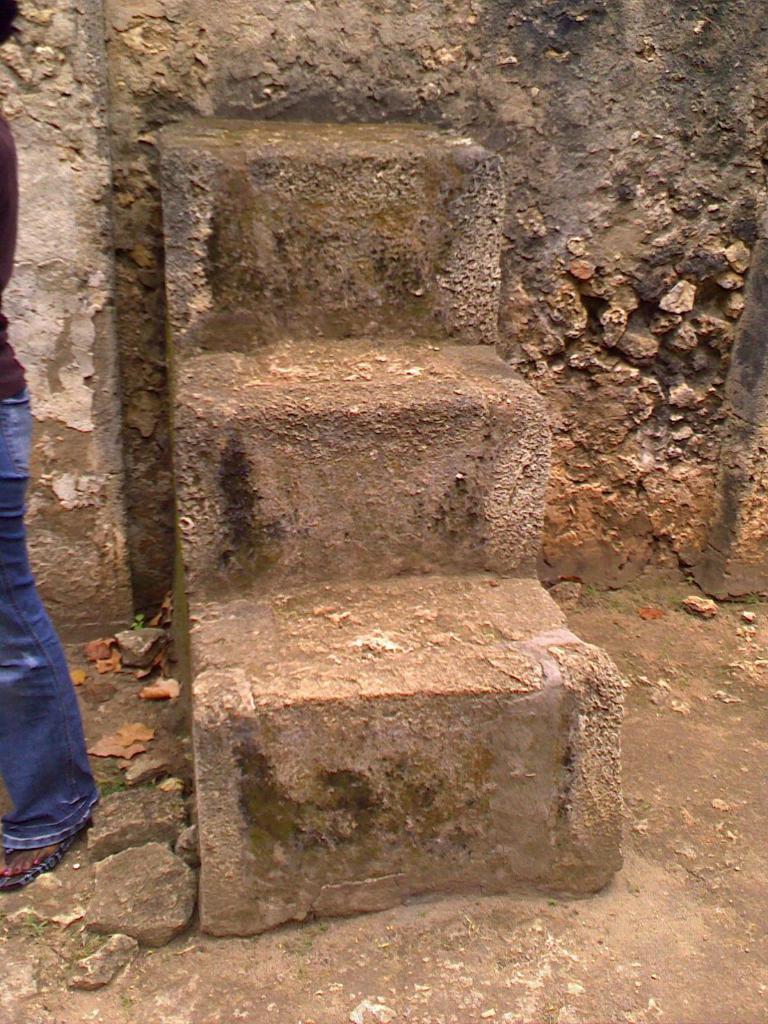Can you describe this image briefly? Here we can see three steps on the wall and this is a wall. On the left we can see a person and small stones on the ground. 